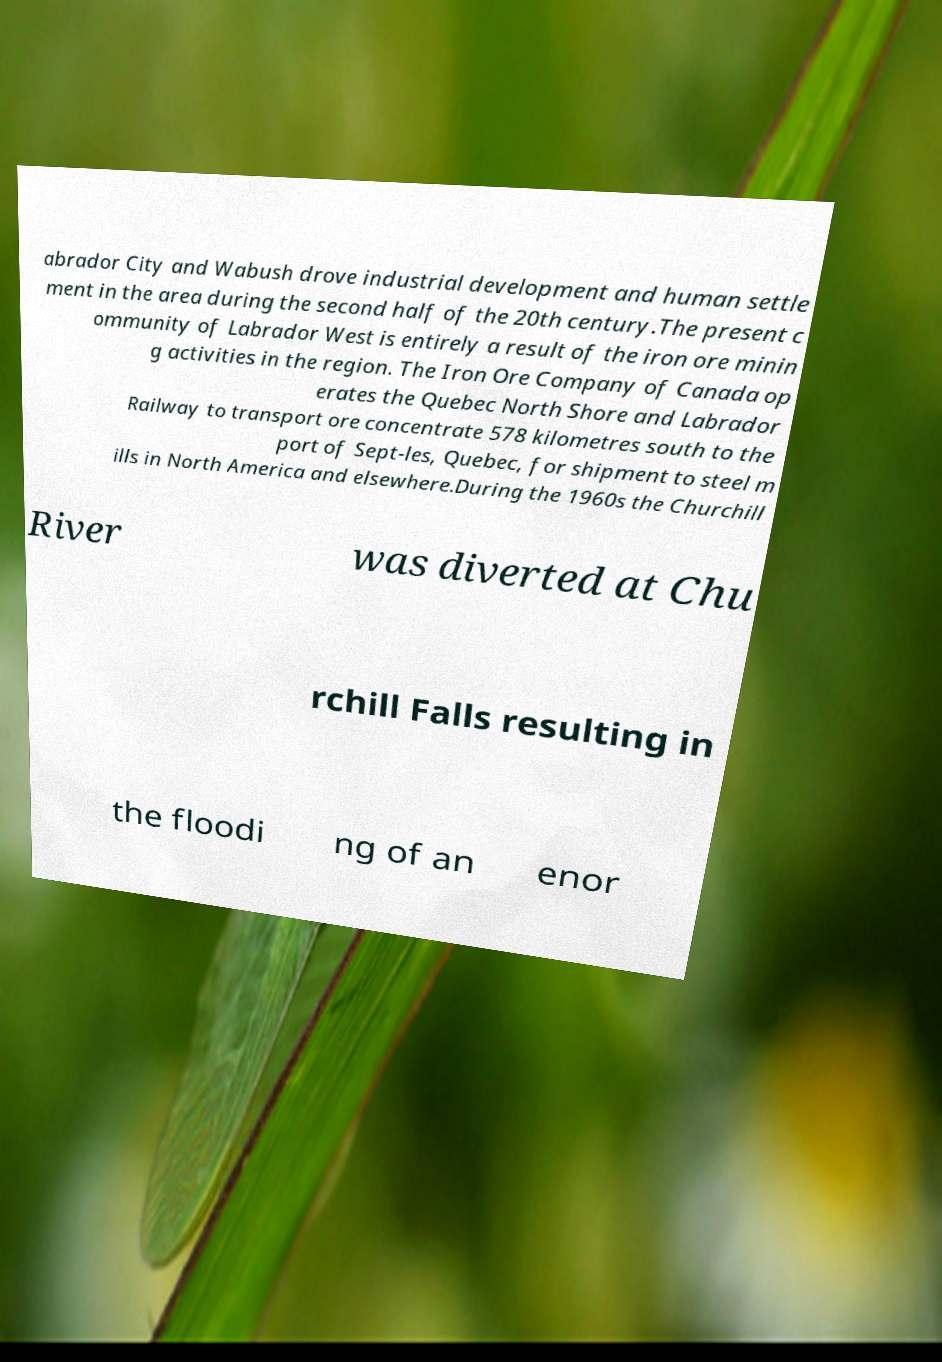For documentation purposes, I need the text within this image transcribed. Could you provide that? abrador City and Wabush drove industrial development and human settle ment in the area during the second half of the 20th century.The present c ommunity of Labrador West is entirely a result of the iron ore minin g activities in the region. The Iron Ore Company of Canada op erates the Quebec North Shore and Labrador Railway to transport ore concentrate 578 kilometres south to the port of Sept-les, Quebec, for shipment to steel m ills in North America and elsewhere.During the 1960s the Churchill River was diverted at Chu rchill Falls resulting in the floodi ng of an enor 